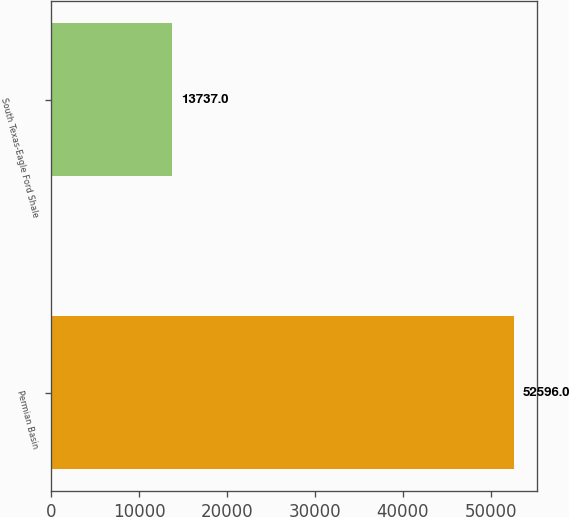Convert chart. <chart><loc_0><loc_0><loc_500><loc_500><bar_chart><fcel>Permian Basin<fcel>South Texas-Eagle Ford Shale<nl><fcel>52596<fcel>13737<nl></chart> 